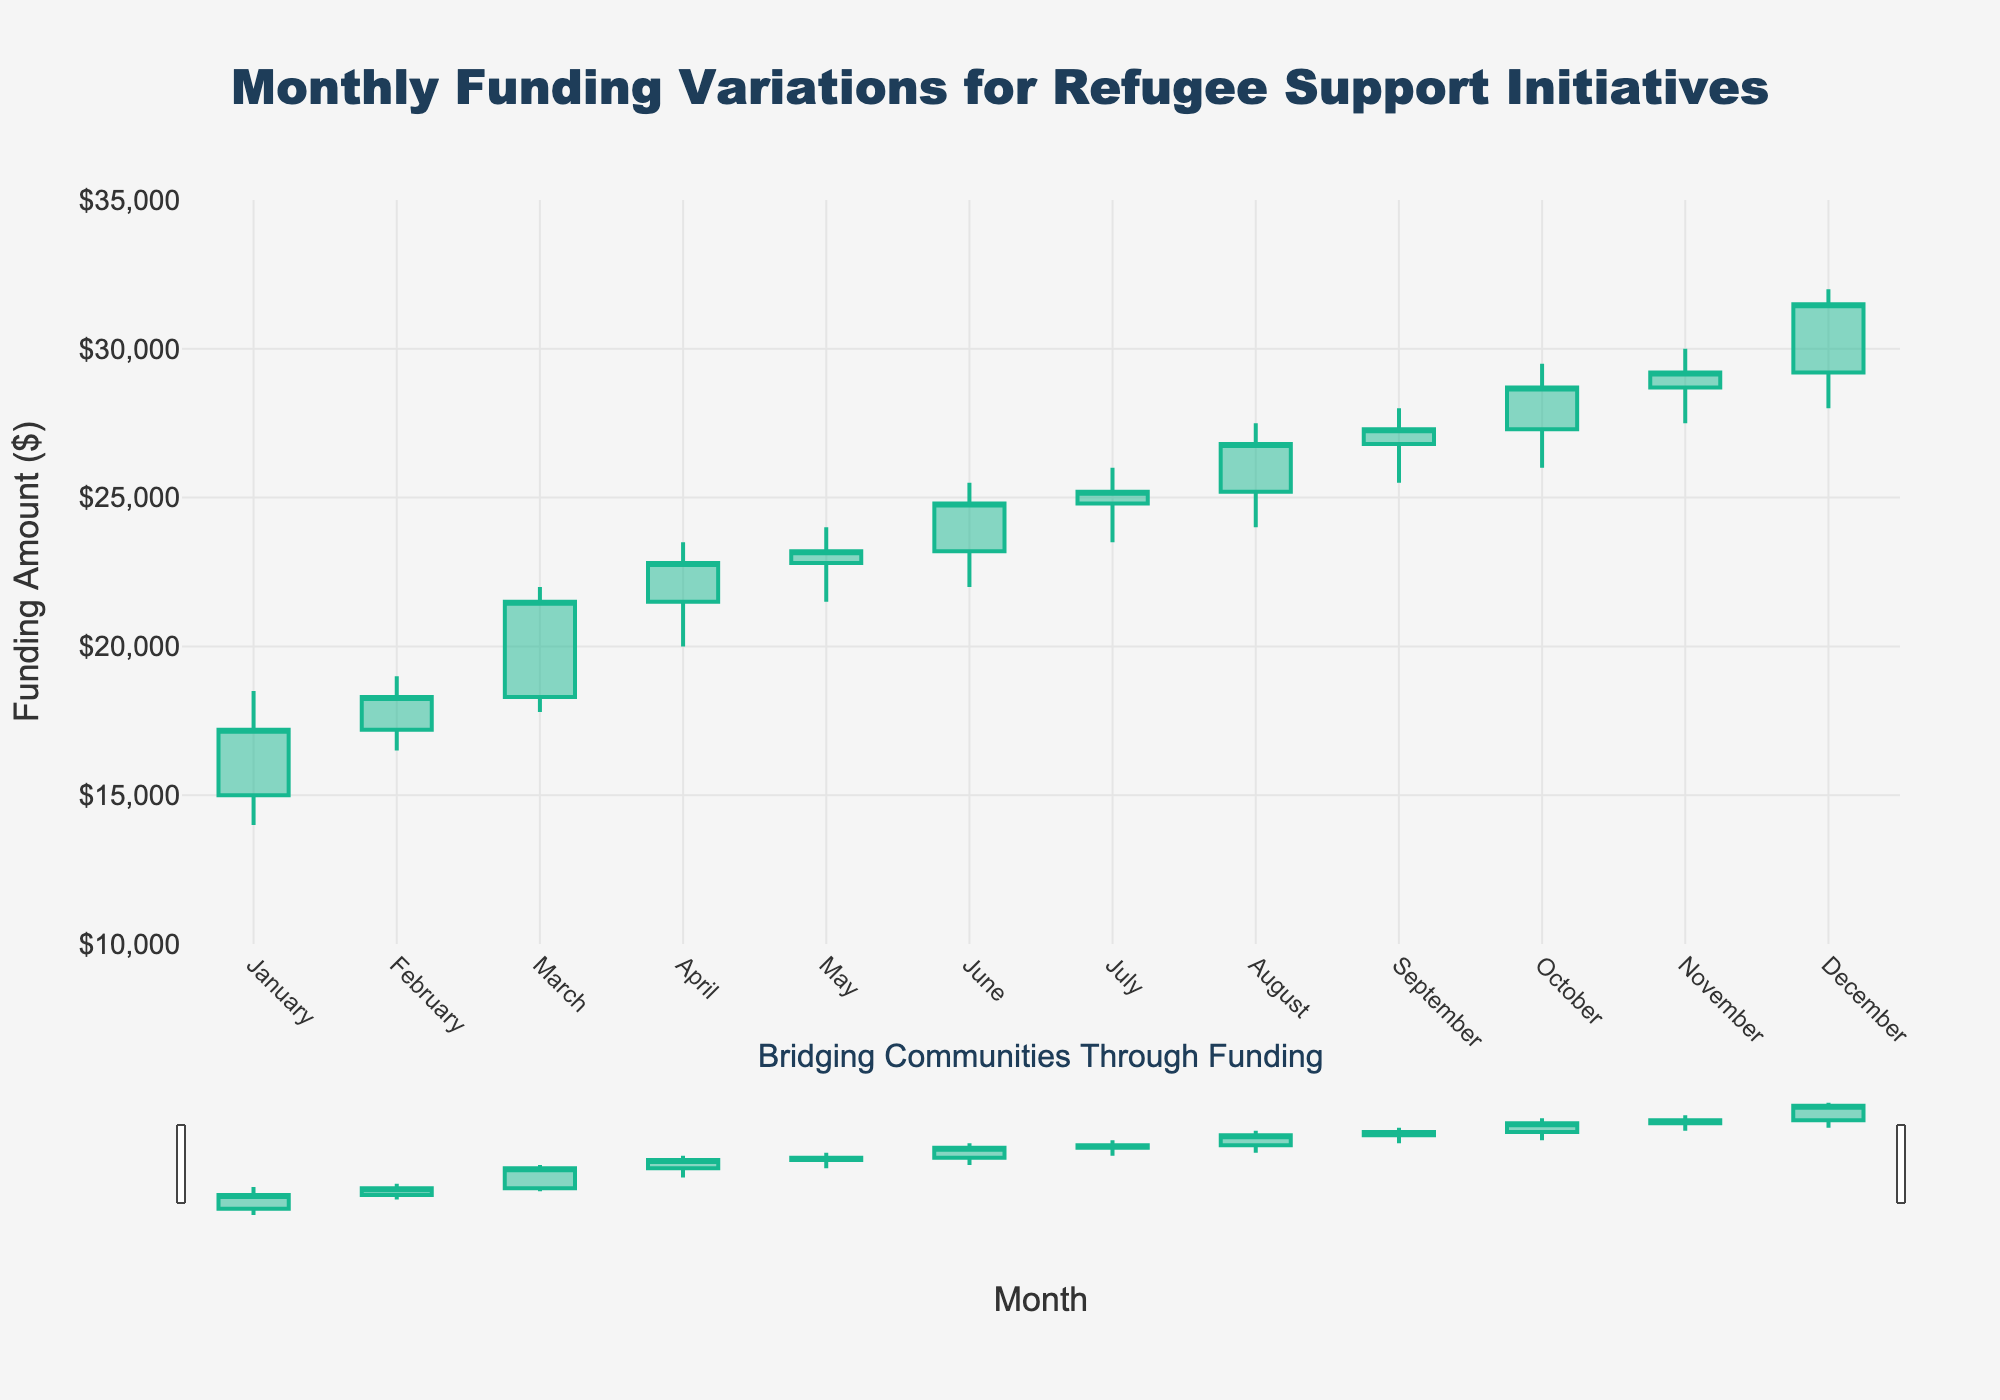How many months are represented in the chart? By looking at the x-axis, we can count the number of data points corresponding to the months listed. We see 12 months from January to December.
Answer: 12 What is the highest funding received in any month? We can identify the maximum value on the high values indicated by the candlestick's highest point. The highest funding is in December with a high value of $32,000.
Answer: $32,000 Which month had the lowest closing funding amount? The closing values are the ones indicated by the small horizontal dash on the right of each candlestick. The lowest closing value is in January with a closing amount of $17,200.
Answer: January What is the average high funding value across all months? To calculate the average high funding value: (18500 + 19000 + 22000 + 23500 + 24000 + 25500 + 26000 + 27500 + 28000 + 29500 + 30000 + 32000) / 12 = 25,125.
Answer: $25,125 Compare the opening and closing funding amounts for February. Which one is higher? From the data, we can see that February has an opening value of $17,200 and a closing value of $18,300. Comparing these, the closing value is higher.
Answer: Closing In which month did funding experience the highest fluctuation? Funding fluctuation can be found by subtracting the low value from the high value for each month. December shows the highest difference (32000 - 28000 = 4000).
Answer: December What was the total funding increase from January's open to December's close? The open value for January is $15,000, and the close value for December is $31,500. The total increase is $31,500 - $15,000 = $16,500.
Answer: $16,500 Did the funding ever decrease from one month to the next? Comparing the closing values month by month, we see that there was no decrease as each closing value is higher than the previous month.
Answer: No Which color is used to represent months with increasing closing values? The candlesticks indicating an increase in funding are colored green (increasing line color).
Answer: Green How many months experienced funding closing above $25,000? By examining the closing values, we see that from June to December, the funding closed above $25,000. This is 7 months.
Answer: 7 